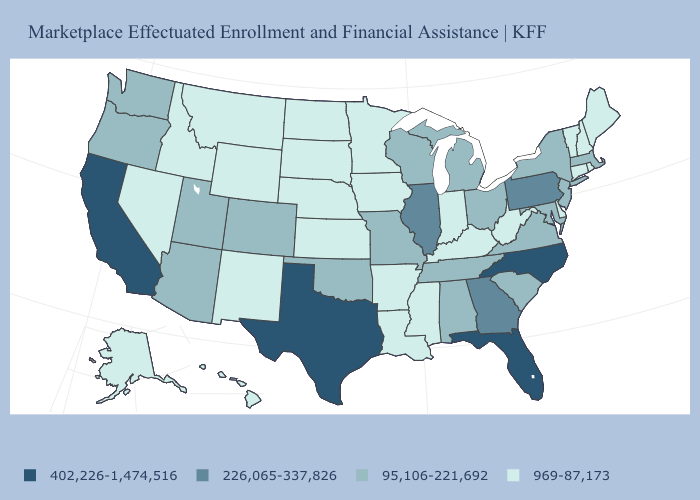Among the states that border Texas , which have the lowest value?
Be succinct. Arkansas, Louisiana, New Mexico. What is the lowest value in states that border West Virginia?
Answer briefly. 969-87,173. What is the lowest value in the West?
Short answer required. 969-87,173. Name the states that have a value in the range 95,106-221,692?
Write a very short answer. Alabama, Arizona, Colorado, Maryland, Massachusetts, Michigan, Missouri, New Jersey, New York, Ohio, Oklahoma, Oregon, South Carolina, Tennessee, Utah, Virginia, Washington, Wisconsin. Name the states that have a value in the range 226,065-337,826?
Answer briefly. Georgia, Illinois, Pennsylvania. Does Michigan have the lowest value in the MidWest?
Be succinct. No. What is the value of West Virginia?
Answer briefly. 969-87,173. Name the states that have a value in the range 95,106-221,692?
Quick response, please. Alabama, Arizona, Colorado, Maryland, Massachusetts, Michigan, Missouri, New Jersey, New York, Ohio, Oklahoma, Oregon, South Carolina, Tennessee, Utah, Virginia, Washington, Wisconsin. Does the first symbol in the legend represent the smallest category?
Be succinct. No. What is the highest value in the Northeast ?
Write a very short answer. 226,065-337,826. What is the value of North Carolina?
Write a very short answer. 402,226-1,474,516. Does North Carolina have the highest value in the USA?
Answer briefly. Yes. Does Illinois have a higher value than Arizona?
Answer briefly. Yes. 